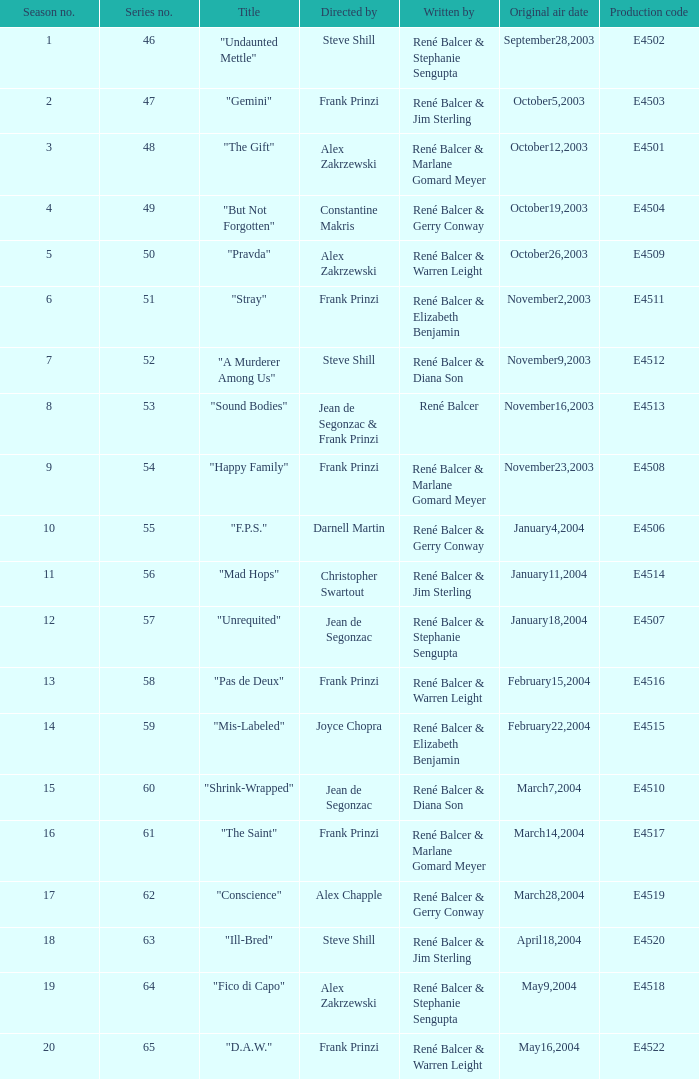Who wrote the episode with e4515 as the production code? René Balcer & Elizabeth Benjamin. 